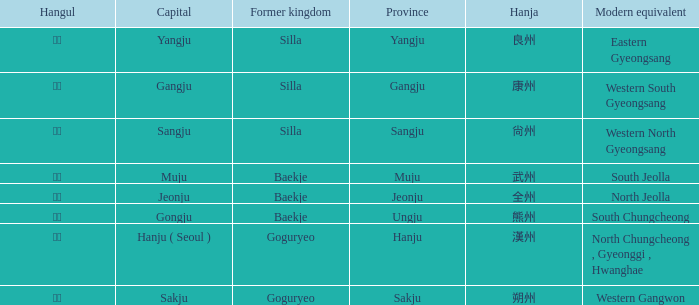What is the modern equivalent of the former kingdom "silla" with the hanja 尙州? 1.0. 